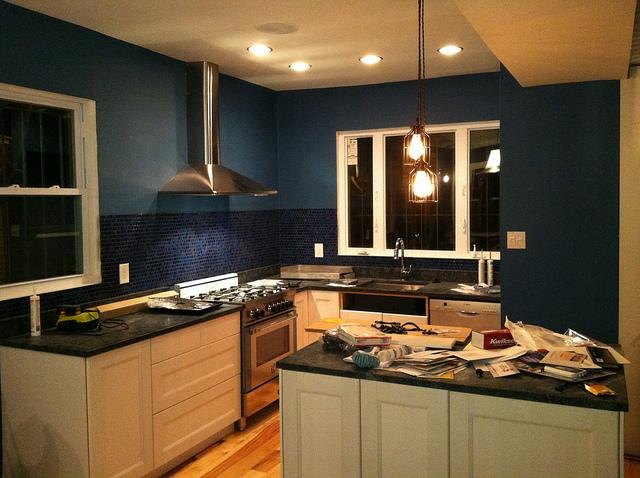What kind of backsplash has been attached to the wall? tile 